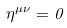Convert formula to latex. <formula><loc_0><loc_0><loc_500><loc_500>\eta ^ { \mu \nu } = 0</formula> 